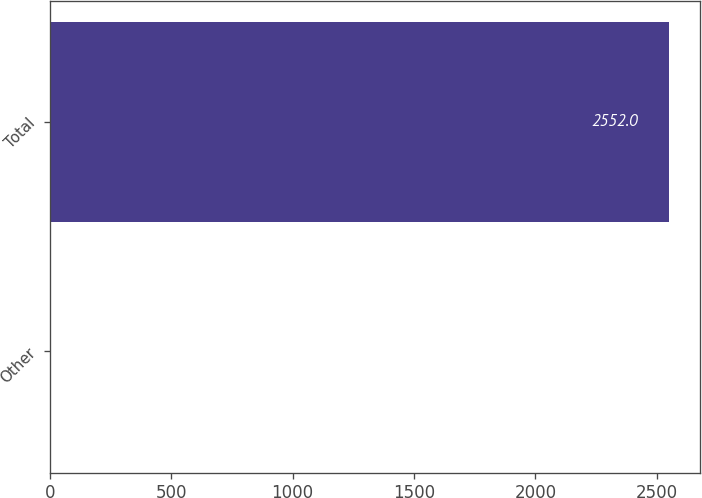<chart> <loc_0><loc_0><loc_500><loc_500><bar_chart><fcel>Other<fcel>Total<nl><fcel>4<fcel>2552<nl></chart> 